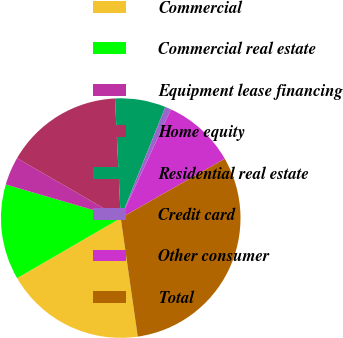Convert chart. <chart><loc_0><loc_0><loc_500><loc_500><pie_chart><fcel>Commercial<fcel>Commercial real estate<fcel>Equipment lease financing<fcel>Home equity<fcel>Residential real estate<fcel>Credit card<fcel>Other consumer<fcel>Total<nl><fcel>18.91%<fcel>12.88%<fcel>3.82%<fcel>15.9%<fcel>6.84%<fcel>0.81%<fcel>9.86%<fcel>30.98%<nl></chart> 